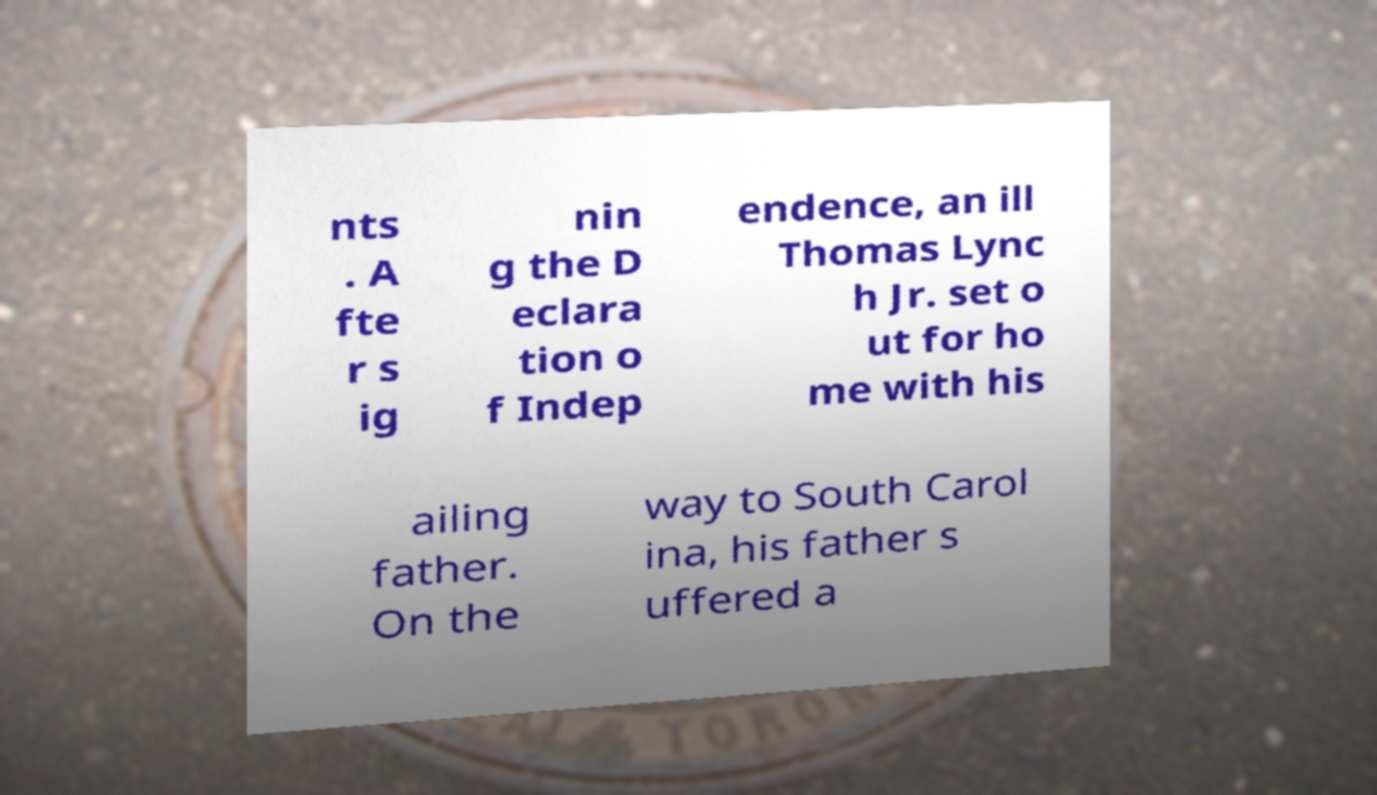I need the written content from this picture converted into text. Can you do that? nts . A fte r s ig nin g the D eclara tion o f Indep endence, an ill Thomas Lync h Jr. set o ut for ho me with his ailing father. On the way to South Carol ina, his father s uffered a 